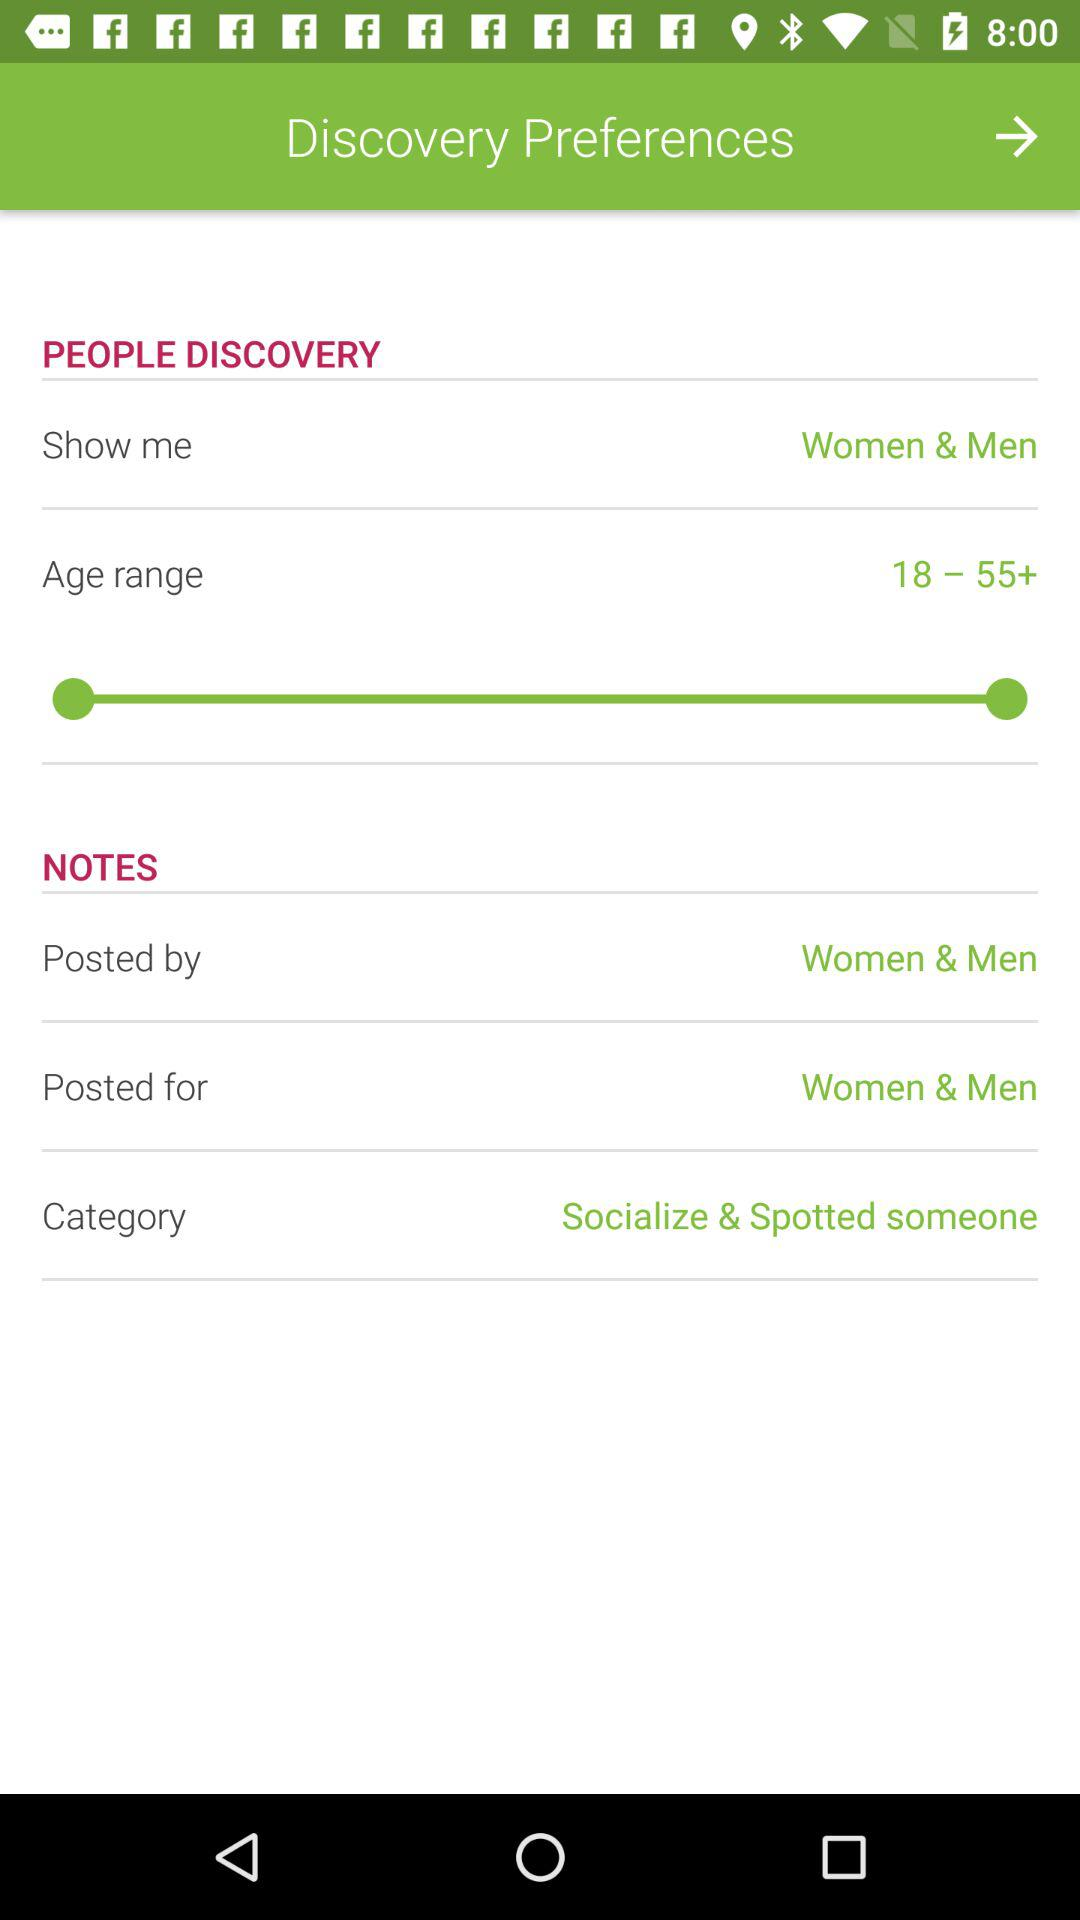What is the age range? The age range is from 18 to more than 55. 